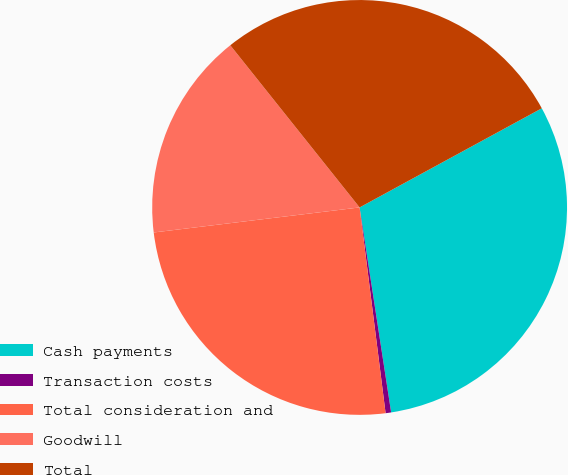<chart> <loc_0><loc_0><loc_500><loc_500><pie_chart><fcel>Cash payments<fcel>Transaction costs<fcel>Total consideration and<fcel>Goodwill<fcel>Total<nl><fcel>30.5%<fcel>0.43%<fcel>25.07%<fcel>16.21%<fcel>27.78%<nl></chart> 